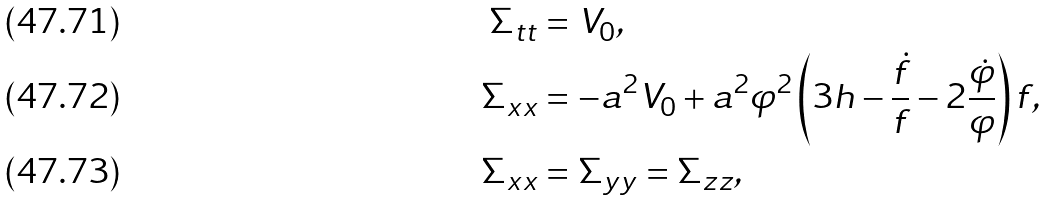<formula> <loc_0><loc_0><loc_500><loc_500>\Sigma _ { t t } & = V _ { 0 } , \\ \Sigma _ { x x } & = - a ^ { 2 } V _ { 0 } + a ^ { 2 } \varphi ^ { 2 } \left ( 3 h - \frac { \dot { f } } { f } - 2 \frac { \dot { \varphi } } { \varphi } \right ) f , \\ \Sigma _ { x x } & = \Sigma _ { y y } = \Sigma _ { z z } ,</formula> 